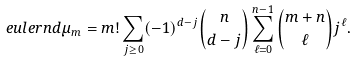Convert formula to latex. <formula><loc_0><loc_0><loc_500><loc_500>\ e u l e r { n } { d } \mu _ { m } = m ! \sum _ { j \geq 0 } ( - 1 ) ^ { d - j } \binom { n } { d - j } \sum _ { \ell = 0 } ^ { n - 1 } \binom { m + n } { \ell } j ^ { \ell } .</formula> 